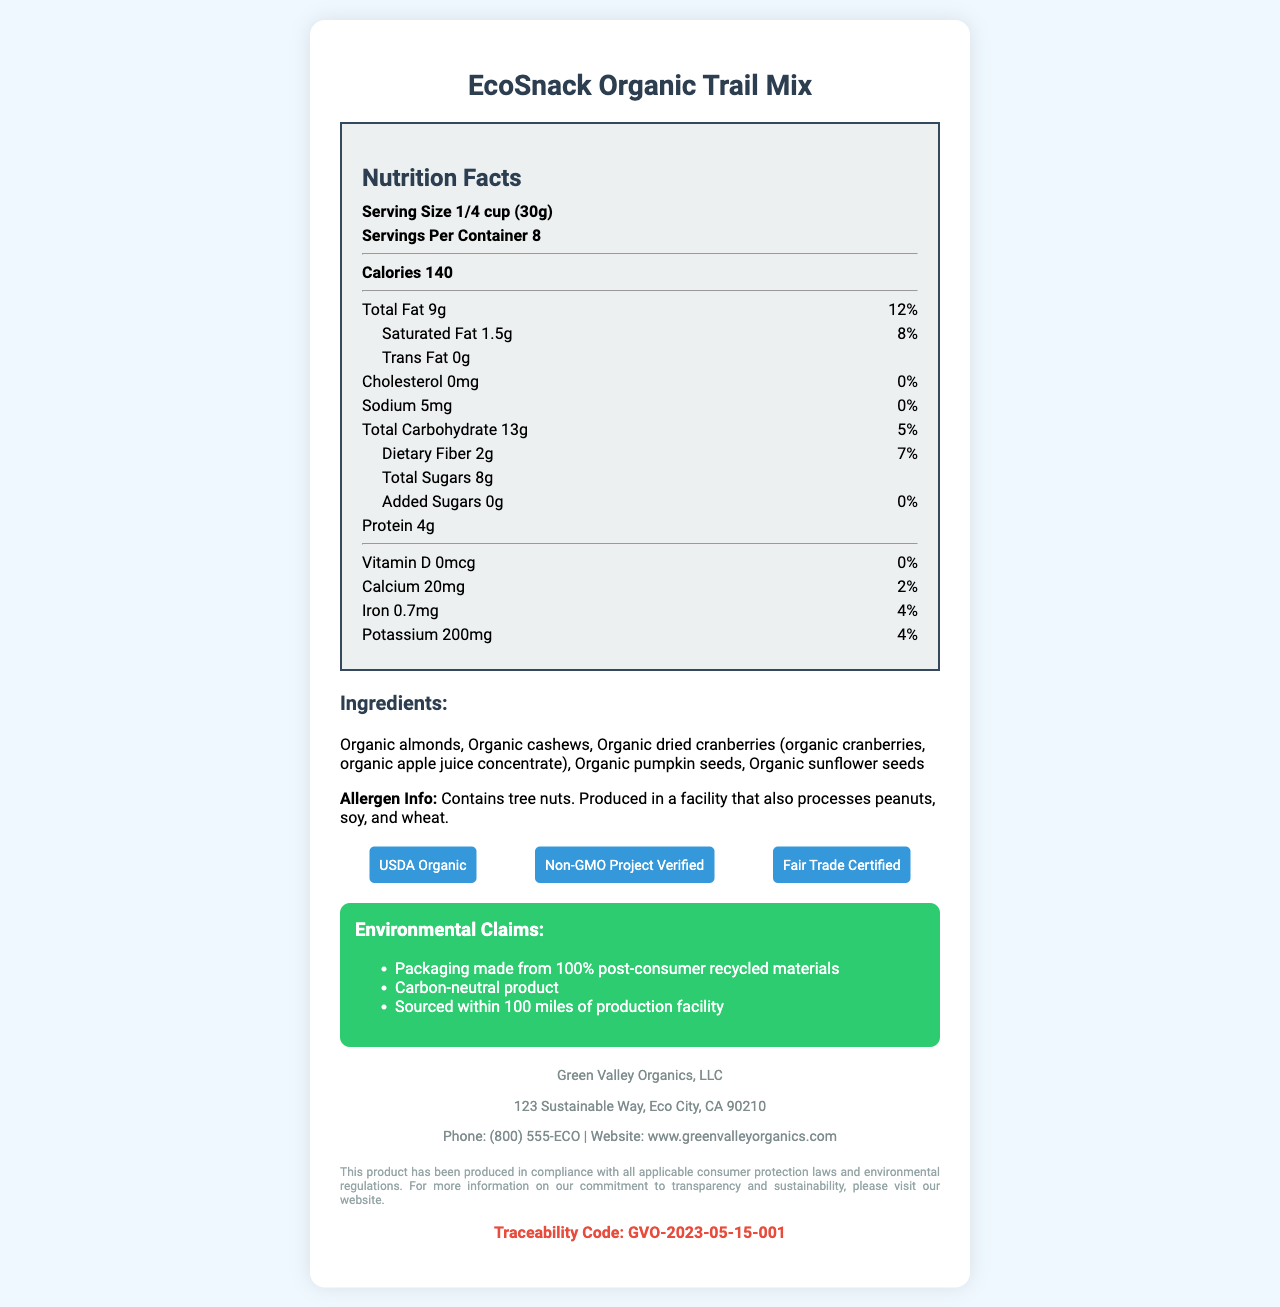What is the serving size for EcoSnack Organic Trail Mix? The serving size is clearly stated at the beginning of the nutrition facts section.
Answer: 1/4 cup (30g) How many calories are in one serving of EcoSnack Organic Trail Mix? The number of calories per serving is listed prominently in the nutrition facts section.
Answer: 140 List two organic ingredients found in EcoSnack Organic Trail Mix. The ingredients list includes several organic items, of which organic almonds and organic cashews are two examples.
Answer: Organic almonds, Organic cashews What is the daily value percentage of total fat in one serving? The daily value percentage for total fat is listed next to the amount of total fat in the nutrition facts section.
Answer: 12% Does EcoSnack Organic Trail Mix contain any trans fat? The trans fat amount is listed as 0g in the nutrition facts.
Answer: No Which certifications does EcoSnack Organic Trail Mix have? A. Gluten-Free B. USDA Organic C. Fair Trade Certified D. Non-GMO Project Verified The document lists USDA Organic, Non-GMO Project Verified, and Fair Trade Certified as its certifications.
Answer: B, C, D What is the company name that produces EcoSnack Organic Trail Mix? The company information section specifies that Green Valley Organics, LLC produces EcoSnack Organic Trail Mix.
Answer: Green Valley Organics, LLC Is EcoSnack Organic Trail Mix a carbon-neutral product? Yes/No The environmental claims section states that the product is carbon-neutral.
Answer: Yes Summarize the main idea of the document. The document includes comprehensive information on nutritional values, ingredients, certifications, and environmental efforts while ensuring adherence to consumer protection and environmental regulations.
Answer: The document provides a detailed nutrition facts label for EcoSnack Organic Trail Mix, highlighting its nutritional content, organic ingredients, allergen information, certifications, environmental claims, and compliance with consumer protection laws. Can the exact recipe for EcoSnack Organic Trail Mix be determined from the document? The document lists the ingredients but does not provide the exact recipe or proportions beyond the serving size.
Answer: No What is the daily value percentage of dietary fiber per serving? The daily value percentage for dietary fiber is listed next to the amount of dietary fiber in the nutrition facts section.
Answer: 7% Which allergen is specifically listed in the document? A. Soy B. Peanuts C. Tree nuts D. Dairy The allergen information mentions tree nuts specifically.
Answer: C Does the document indicate whether the product is compliant with California Proposition 65? The consumer protection compliance section lists compliance with California Proposition 65.
Answer: Yes How many servings are in one container of EcoSnack Organic Trail Mix? The number of servings per container is listed at the beginning of the nutrition facts section.
Answer: 8 servings 